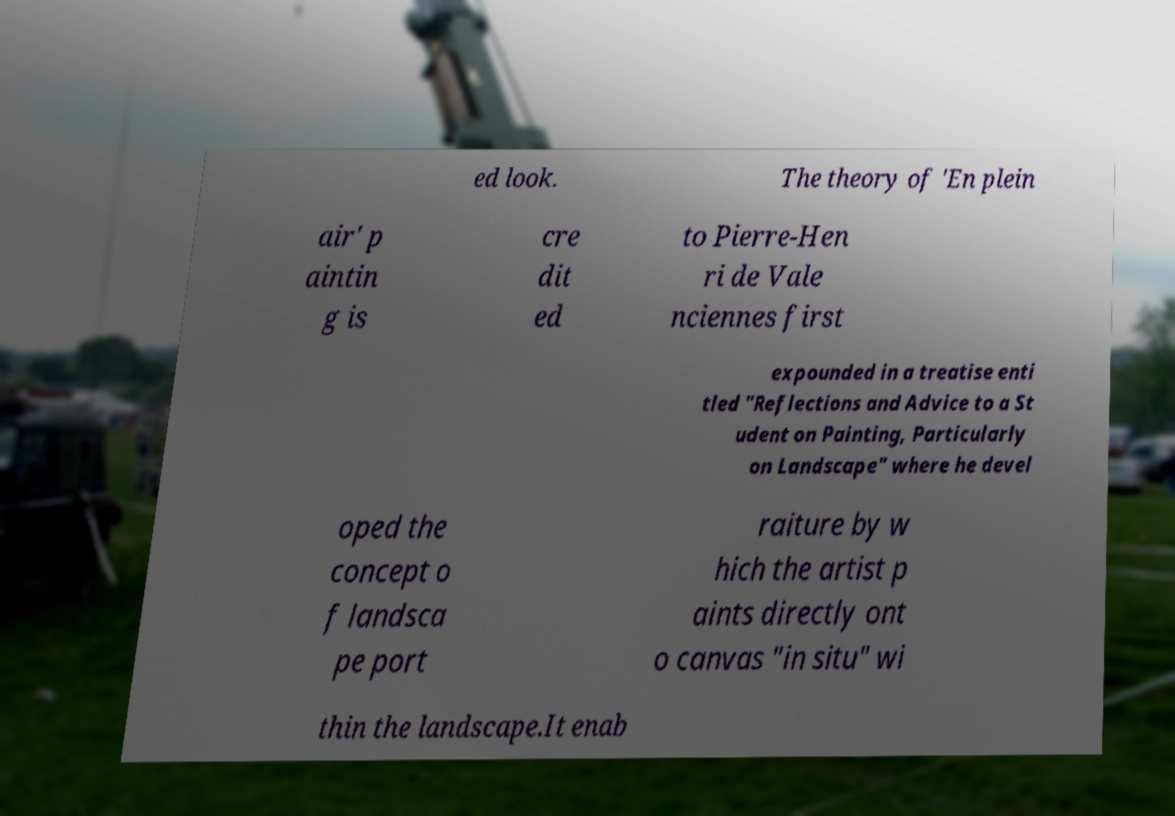There's text embedded in this image that I need extracted. Can you transcribe it verbatim? ed look. The theory of 'En plein air' p aintin g is cre dit ed to Pierre-Hen ri de Vale nciennes first expounded in a treatise enti tled "Reflections and Advice to a St udent on Painting, Particularly on Landscape" where he devel oped the concept o f landsca pe port raiture by w hich the artist p aints directly ont o canvas "in situ" wi thin the landscape.It enab 